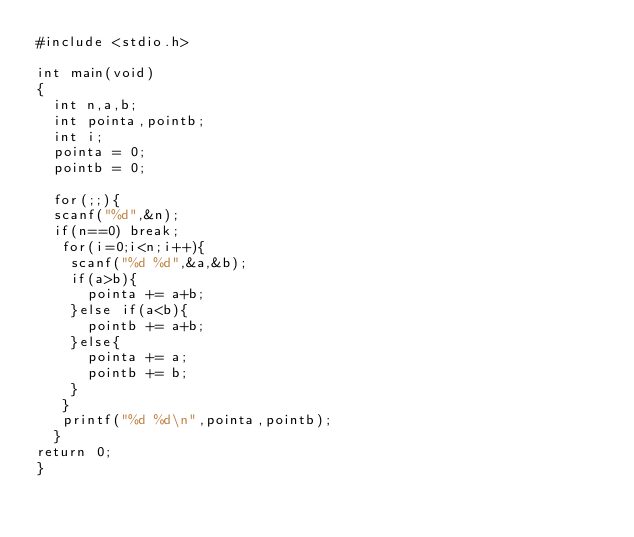<code> <loc_0><loc_0><loc_500><loc_500><_C_>#include <stdio.h>

int main(void)
{
	int n,a,b;
	int pointa,pointb;
	int i;
	pointa = 0;
	pointb = 0;
	
	for(;;){
	scanf("%d",&n);
	if(n==0) break;
	 for(i=0;i<n;i++){
	 	scanf("%d %d",&a,&b);
	 	if(a>b){
	 		pointa += a+b;
	 	}else if(a<b){
	 		pointb += a+b;
	 	}else{
	 		pointa += a;
	 		pointb += b;
	 	}
	 }
	 printf("%d %d\n",pointa,pointb);
	}
return 0;
}</code> 